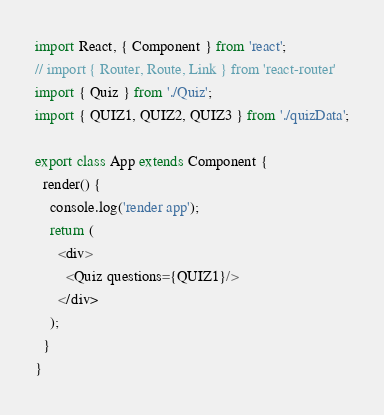<code> <loc_0><loc_0><loc_500><loc_500><_JavaScript_>import React, { Component } from 'react';
// import { Router, Route, Link } from 'react-router'
import { Quiz } from './Quiz';
import { QUIZ1, QUIZ2, QUIZ3 } from './quizData';

export class App extends Component {
  render() {
    console.log('render app');
    return (
      <div>
        <Quiz questions={QUIZ1}/>
      </div>
    );
  }
}
</code> 